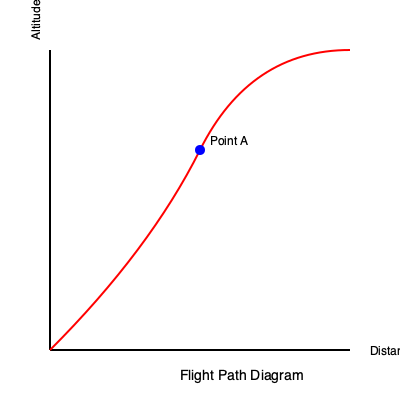Given the flight path diagram, what type of maneuver is the aircraft likely performing at Point A, and what potential hazard should be considered? To interpret the flight path diagram and identify the maneuver at Point A, follow these steps:

1. Analyze the overall shape of the flight path:
   The red curve represents the aircraft's trajectory from left to right.

2. Observe the axes:
   The x-axis represents distance, and the y-axis represents altitude.

3. Examine the curve's characteristics:
   The path starts with a steep climb, then gradually levels off before descending.

4. Locate Point A:
   It's at the top of the curve where the ascent transitions to descent.

5. Identify the maneuver:
   At Point A, the aircraft is at its peak altitude and is transitioning from climbing to descending. This indicates the aircraft is likely performing a "cruise" or "level-off" maneuver.

6. Consider potential hazards:
   At the highest point of the flight path, the aircraft may be near its service ceiling. This could lead to:
   a) Reduced engine performance due to thinner air
   b) Potential for aerodynamic stall due to lower air density
   c) Increased fuel consumption to maintain altitude

7. Recognize the importance:
   As a first officer, being aware of this transition point is crucial for maintaining situational awareness, ensuring proper engine management, and preparing for the upcoming descent phase.
Answer: Cruise/level-off maneuver; potential hazard: operating near service ceiling 